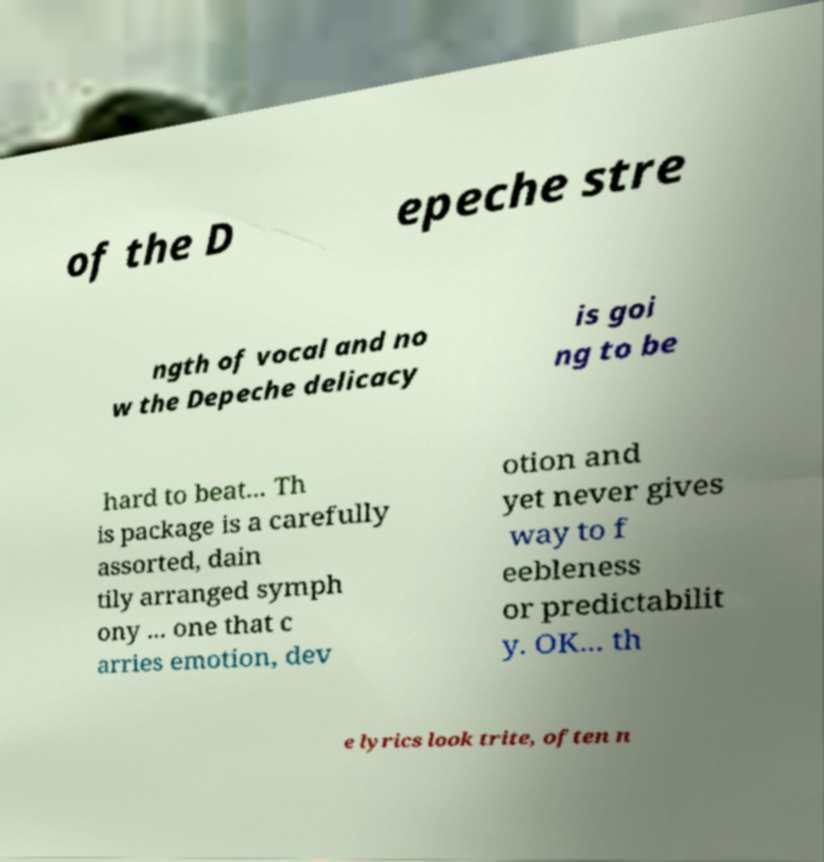What messages or text are displayed in this image? I need them in a readable, typed format. of the D epeche stre ngth of vocal and no w the Depeche delicacy is goi ng to be hard to beat... Th is package is a carefully assorted, dain tily arranged symph ony ... one that c arries emotion, dev otion and yet never gives way to f eebleness or predictabilit y. OK... th e lyrics look trite, often n 